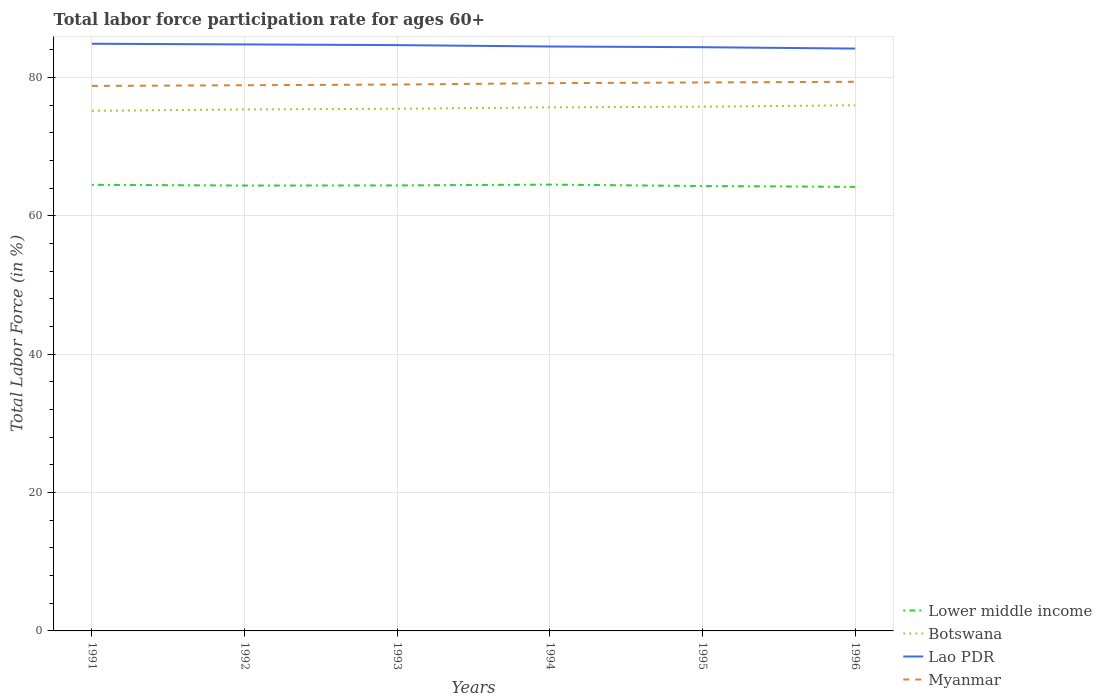Does the line corresponding to Lower middle income intersect with the line corresponding to Botswana?
Your answer should be very brief. No. Is the number of lines equal to the number of legend labels?
Make the answer very short. Yes. Across all years, what is the maximum labor force participation rate in Myanmar?
Your response must be concise. 78.8. In which year was the labor force participation rate in Lower middle income maximum?
Keep it short and to the point. 1996. What is the total labor force participation rate in Myanmar in the graph?
Offer a very short reply. -0.4. What is the difference between the highest and the second highest labor force participation rate in Myanmar?
Offer a very short reply. 0.6. Is the labor force participation rate in Lower middle income strictly greater than the labor force participation rate in Myanmar over the years?
Make the answer very short. Yes. How many lines are there?
Your response must be concise. 4. Are the values on the major ticks of Y-axis written in scientific E-notation?
Make the answer very short. No. Does the graph contain any zero values?
Provide a short and direct response. No. Does the graph contain grids?
Offer a very short reply. Yes. What is the title of the graph?
Your answer should be compact. Total labor force participation rate for ages 60+. Does "United Kingdom" appear as one of the legend labels in the graph?
Offer a very short reply. No. What is the label or title of the X-axis?
Your response must be concise. Years. What is the label or title of the Y-axis?
Make the answer very short. Total Labor Force (in %). What is the Total Labor Force (in %) in Lower middle income in 1991?
Your answer should be very brief. 64.5. What is the Total Labor Force (in %) of Botswana in 1991?
Offer a terse response. 75.2. What is the Total Labor Force (in %) of Lao PDR in 1991?
Your response must be concise. 84.9. What is the Total Labor Force (in %) in Myanmar in 1991?
Keep it short and to the point. 78.8. What is the Total Labor Force (in %) in Lower middle income in 1992?
Ensure brevity in your answer.  64.4. What is the Total Labor Force (in %) in Botswana in 1992?
Make the answer very short. 75.4. What is the Total Labor Force (in %) of Lao PDR in 1992?
Your answer should be very brief. 84.8. What is the Total Labor Force (in %) in Myanmar in 1992?
Your answer should be compact. 78.9. What is the Total Labor Force (in %) in Lower middle income in 1993?
Give a very brief answer. 64.41. What is the Total Labor Force (in %) in Botswana in 1993?
Offer a very short reply. 75.5. What is the Total Labor Force (in %) in Lao PDR in 1993?
Offer a terse response. 84.7. What is the Total Labor Force (in %) of Myanmar in 1993?
Make the answer very short. 79. What is the Total Labor Force (in %) of Lower middle income in 1994?
Provide a short and direct response. 64.53. What is the Total Labor Force (in %) of Botswana in 1994?
Your answer should be compact. 75.7. What is the Total Labor Force (in %) of Lao PDR in 1994?
Your answer should be very brief. 84.5. What is the Total Labor Force (in %) of Myanmar in 1994?
Offer a terse response. 79.2. What is the Total Labor Force (in %) of Lower middle income in 1995?
Offer a terse response. 64.33. What is the Total Labor Force (in %) in Botswana in 1995?
Offer a terse response. 75.8. What is the Total Labor Force (in %) in Lao PDR in 1995?
Your answer should be very brief. 84.4. What is the Total Labor Force (in %) in Myanmar in 1995?
Keep it short and to the point. 79.3. What is the Total Labor Force (in %) in Lower middle income in 1996?
Offer a terse response. 64.2. What is the Total Labor Force (in %) of Botswana in 1996?
Provide a short and direct response. 76. What is the Total Labor Force (in %) in Lao PDR in 1996?
Offer a terse response. 84.2. What is the Total Labor Force (in %) of Myanmar in 1996?
Provide a short and direct response. 79.4. Across all years, what is the maximum Total Labor Force (in %) in Lower middle income?
Your answer should be compact. 64.53. Across all years, what is the maximum Total Labor Force (in %) in Botswana?
Your answer should be compact. 76. Across all years, what is the maximum Total Labor Force (in %) in Lao PDR?
Keep it short and to the point. 84.9. Across all years, what is the maximum Total Labor Force (in %) in Myanmar?
Give a very brief answer. 79.4. Across all years, what is the minimum Total Labor Force (in %) of Lower middle income?
Ensure brevity in your answer.  64.2. Across all years, what is the minimum Total Labor Force (in %) of Botswana?
Offer a very short reply. 75.2. Across all years, what is the minimum Total Labor Force (in %) of Lao PDR?
Your answer should be compact. 84.2. Across all years, what is the minimum Total Labor Force (in %) in Myanmar?
Ensure brevity in your answer.  78.8. What is the total Total Labor Force (in %) of Lower middle income in the graph?
Your response must be concise. 386.37. What is the total Total Labor Force (in %) in Botswana in the graph?
Ensure brevity in your answer.  453.6. What is the total Total Labor Force (in %) in Lao PDR in the graph?
Ensure brevity in your answer.  507.5. What is the total Total Labor Force (in %) of Myanmar in the graph?
Your answer should be very brief. 474.6. What is the difference between the Total Labor Force (in %) of Lower middle income in 1991 and that in 1992?
Your answer should be compact. 0.1. What is the difference between the Total Labor Force (in %) in Botswana in 1991 and that in 1992?
Ensure brevity in your answer.  -0.2. What is the difference between the Total Labor Force (in %) in Myanmar in 1991 and that in 1992?
Provide a succinct answer. -0.1. What is the difference between the Total Labor Force (in %) of Lower middle income in 1991 and that in 1993?
Offer a terse response. 0.08. What is the difference between the Total Labor Force (in %) in Botswana in 1991 and that in 1993?
Ensure brevity in your answer.  -0.3. What is the difference between the Total Labor Force (in %) of Lao PDR in 1991 and that in 1993?
Offer a very short reply. 0.2. What is the difference between the Total Labor Force (in %) in Myanmar in 1991 and that in 1993?
Your answer should be very brief. -0.2. What is the difference between the Total Labor Force (in %) of Lower middle income in 1991 and that in 1994?
Provide a succinct answer. -0.03. What is the difference between the Total Labor Force (in %) in Myanmar in 1991 and that in 1994?
Keep it short and to the point. -0.4. What is the difference between the Total Labor Force (in %) of Lower middle income in 1991 and that in 1995?
Offer a terse response. 0.17. What is the difference between the Total Labor Force (in %) in Botswana in 1991 and that in 1995?
Make the answer very short. -0.6. What is the difference between the Total Labor Force (in %) of Lower middle income in 1991 and that in 1996?
Make the answer very short. 0.29. What is the difference between the Total Labor Force (in %) of Botswana in 1991 and that in 1996?
Provide a short and direct response. -0.8. What is the difference between the Total Labor Force (in %) of Lao PDR in 1991 and that in 1996?
Make the answer very short. 0.7. What is the difference between the Total Labor Force (in %) of Lower middle income in 1992 and that in 1993?
Provide a short and direct response. -0.02. What is the difference between the Total Labor Force (in %) of Myanmar in 1992 and that in 1993?
Keep it short and to the point. -0.1. What is the difference between the Total Labor Force (in %) of Lower middle income in 1992 and that in 1994?
Provide a succinct answer. -0.13. What is the difference between the Total Labor Force (in %) of Lao PDR in 1992 and that in 1994?
Offer a terse response. 0.3. What is the difference between the Total Labor Force (in %) in Lower middle income in 1992 and that in 1995?
Offer a terse response. 0.07. What is the difference between the Total Labor Force (in %) in Botswana in 1992 and that in 1995?
Your response must be concise. -0.4. What is the difference between the Total Labor Force (in %) in Lao PDR in 1992 and that in 1995?
Provide a succinct answer. 0.4. What is the difference between the Total Labor Force (in %) of Myanmar in 1992 and that in 1995?
Keep it short and to the point. -0.4. What is the difference between the Total Labor Force (in %) of Lower middle income in 1992 and that in 1996?
Your answer should be very brief. 0.19. What is the difference between the Total Labor Force (in %) of Lower middle income in 1993 and that in 1994?
Provide a succinct answer. -0.12. What is the difference between the Total Labor Force (in %) in Myanmar in 1993 and that in 1994?
Your response must be concise. -0.2. What is the difference between the Total Labor Force (in %) in Lower middle income in 1993 and that in 1995?
Offer a very short reply. 0.08. What is the difference between the Total Labor Force (in %) in Lower middle income in 1993 and that in 1996?
Offer a very short reply. 0.21. What is the difference between the Total Labor Force (in %) in Botswana in 1993 and that in 1996?
Give a very brief answer. -0.5. What is the difference between the Total Labor Force (in %) of Myanmar in 1993 and that in 1996?
Offer a terse response. -0.4. What is the difference between the Total Labor Force (in %) in Lower middle income in 1994 and that in 1995?
Your response must be concise. 0.2. What is the difference between the Total Labor Force (in %) in Botswana in 1994 and that in 1995?
Give a very brief answer. -0.1. What is the difference between the Total Labor Force (in %) of Lao PDR in 1994 and that in 1995?
Your answer should be very brief. 0.1. What is the difference between the Total Labor Force (in %) in Lower middle income in 1994 and that in 1996?
Provide a succinct answer. 0.33. What is the difference between the Total Labor Force (in %) in Lao PDR in 1994 and that in 1996?
Ensure brevity in your answer.  0.3. What is the difference between the Total Labor Force (in %) in Lower middle income in 1995 and that in 1996?
Make the answer very short. 0.13. What is the difference between the Total Labor Force (in %) of Botswana in 1995 and that in 1996?
Ensure brevity in your answer.  -0.2. What is the difference between the Total Labor Force (in %) of Lower middle income in 1991 and the Total Labor Force (in %) of Botswana in 1992?
Your answer should be compact. -10.9. What is the difference between the Total Labor Force (in %) in Lower middle income in 1991 and the Total Labor Force (in %) in Lao PDR in 1992?
Provide a succinct answer. -20.3. What is the difference between the Total Labor Force (in %) in Lower middle income in 1991 and the Total Labor Force (in %) in Myanmar in 1992?
Offer a terse response. -14.4. What is the difference between the Total Labor Force (in %) in Botswana in 1991 and the Total Labor Force (in %) in Myanmar in 1992?
Your answer should be compact. -3.7. What is the difference between the Total Labor Force (in %) of Lower middle income in 1991 and the Total Labor Force (in %) of Botswana in 1993?
Provide a succinct answer. -11. What is the difference between the Total Labor Force (in %) in Lower middle income in 1991 and the Total Labor Force (in %) in Lao PDR in 1993?
Provide a succinct answer. -20.2. What is the difference between the Total Labor Force (in %) of Lower middle income in 1991 and the Total Labor Force (in %) of Myanmar in 1993?
Your response must be concise. -14.5. What is the difference between the Total Labor Force (in %) in Botswana in 1991 and the Total Labor Force (in %) in Lao PDR in 1993?
Offer a very short reply. -9.5. What is the difference between the Total Labor Force (in %) in Lao PDR in 1991 and the Total Labor Force (in %) in Myanmar in 1993?
Keep it short and to the point. 5.9. What is the difference between the Total Labor Force (in %) in Lower middle income in 1991 and the Total Labor Force (in %) in Botswana in 1994?
Offer a very short reply. -11.2. What is the difference between the Total Labor Force (in %) in Lower middle income in 1991 and the Total Labor Force (in %) in Lao PDR in 1994?
Offer a terse response. -20. What is the difference between the Total Labor Force (in %) of Lower middle income in 1991 and the Total Labor Force (in %) of Myanmar in 1994?
Keep it short and to the point. -14.7. What is the difference between the Total Labor Force (in %) in Botswana in 1991 and the Total Labor Force (in %) in Myanmar in 1994?
Offer a terse response. -4. What is the difference between the Total Labor Force (in %) in Lao PDR in 1991 and the Total Labor Force (in %) in Myanmar in 1994?
Your response must be concise. 5.7. What is the difference between the Total Labor Force (in %) of Lower middle income in 1991 and the Total Labor Force (in %) of Botswana in 1995?
Your answer should be very brief. -11.3. What is the difference between the Total Labor Force (in %) in Lower middle income in 1991 and the Total Labor Force (in %) in Lao PDR in 1995?
Your answer should be compact. -19.9. What is the difference between the Total Labor Force (in %) of Lower middle income in 1991 and the Total Labor Force (in %) of Myanmar in 1995?
Ensure brevity in your answer.  -14.8. What is the difference between the Total Labor Force (in %) in Botswana in 1991 and the Total Labor Force (in %) in Myanmar in 1995?
Give a very brief answer. -4.1. What is the difference between the Total Labor Force (in %) of Lower middle income in 1991 and the Total Labor Force (in %) of Botswana in 1996?
Provide a short and direct response. -11.5. What is the difference between the Total Labor Force (in %) in Lower middle income in 1991 and the Total Labor Force (in %) in Lao PDR in 1996?
Your answer should be very brief. -19.7. What is the difference between the Total Labor Force (in %) of Lower middle income in 1991 and the Total Labor Force (in %) of Myanmar in 1996?
Offer a very short reply. -14.9. What is the difference between the Total Labor Force (in %) of Botswana in 1991 and the Total Labor Force (in %) of Myanmar in 1996?
Your response must be concise. -4.2. What is the difference between the Total Labor Force (in %) of Lao PDR in 1991 and the Total Labor Force (in %) of Myanmar in 1996?
Offer a very short reply. 5.5. What is the difference between the Total Labor Force (in %) in Lower middle income in 1992 and the Total Labor Force (in %) in Botswana in 1993?
Make the answer very short. -11.1. What is the difference between the Total Labor Force (in %) in Lower middle income in 1992 and the Total Labor Force (in %) in Lao PDR in 1993?
Ensure brevity in your answer.  -20.3. What is the difference between the Total Labor Force (in %) of Lower middle income in 1992 and the Total Labor Force (in %) of Myanmar in 1993?
Your answer should be compact. -14.6. What is the difference between the Total Labor Force (in %) in Botswana in 1992 and the Total Labor Force (in %) in Lao PDR in 1993?
Keep it short and to the point. -9.3. What is the difference between the Total Labor Force (in %) in Botswana in 1992 and the Total Labor Force (in %) in Myanmar in 1993?
Give a very brief answer. -3.6. What is the difference between the Total Labor Force (in %) in Lower middle income in 1992 and the Total Labor Force (in %) in Botswana in 1994?
Your response must be concise. -11.3. What is the difference between the Total Labor Force (in %) in Lower middle income in 1992 and the Total Labor Force (in %) in Lao PDR in 1994?
Keep it short and to the point. -20.1. What is the difference between the Total Labor Force (in %) of Lower middle income in 1992 and the Total Labor Force (in %) of Myanmar in 1994?
Your response must be concise. -14.8. What is the difference between the Total Labor Force (in %) in Lower middle income in 1992 and the Total Labor Force (in %) in Botswana in 1995?
Provide a short and direct response. -11.4. What is the difference between the Total Labor Force (in %) in Lower middle income in 1992 and the Total Labor Force (in %) in Lao PDR in 1995?
Your answer should be very brief. -20. What is the difference between the Total Labor Force (in %) in Lower middle income in 1992 and the Total Labor Force (in %) in Myanmar in 1995?
Make the answer very short. -14.9. What is the difference between the Total Labor Force (in %) of Botswana in 1992 and the Total Labor Force (in %) of Lao PDR in 1995?
Offer a terse response. -9. What is the difference between the Total Labor Force (in %) of Lao PDR in 1992 and the Total Labor Force (in %) of Myanmar in 1995?
Provide a short and direct response. 5.5. What is the difference between the Total Labor Force (in %) of Lower middle income in 1992 and the Total Labor Force (in %) of Botswana in 1996?
Give a very brief answer. -11.6. What is the difference between the Total Labor Force (in %) in Lower middle income in 1992 and the Total Labor Force (in %) in Lao PDR in 1996?
Make the answer very short. -19.8. What is the difference between the Total Labor Force (in %) of Lower middle income in 1992 and the Total Labor Force (in %) of Myanmar in 1996?
Your answer should be compact. -15. What is the difference between the Total Labor Force (in %) in Botswana in 1992 and the Total Labor Force (in %) in Myanmar in 1996?
Your answer should be compact. -4. What is the difference between the Total Labor Force (in %) in Lower middle income in 1993 and the Total Labor Force (in %) in Botswana in 1994?
Offer a terse response. -11.29. What is the difference between the Total Labor Force (in %) in Lower middle income in 1993 and the Total Labor Force (in %) in Lao PDR in 1994?
Offer a very short reply. -20.09. What is the difference between the Total Labor Force (in %) of Lower middle income in 1993 and the Total Labor Force (in %) of Myanmar in 1994?
Provide a short and direct response. -14.79. What is the difference between the Total Labor Force (in %) in Lower middle income in 1993 and the Total Labor Force (in %) in Botswana in 1995?
Provide a succinct answer. -11.39. What is the difference between the Total Labor Force (in %) of Lower middle income in 1993 and the Total Labor Force (in %) of Lao PDR in 1995?
Your answer should be very brief. -19.99. What is the difference between the Total Labor Force (in %) in Lower middle income in 1993 and the Total Labor Force (in %) in Myanmar in 1995?
Your answer should be very brief. -14.89. What is the difference between the Total Labor Force (in %) in Lower middle income in 1993 and the Total Labor Force (in %) in Botswana in 1996?
Your answer should be very brief. -11.59. What is the difference between the Total Labor Force (in %) in Lower middle income in 1993 and the Total Labor Force (in %) in Lao PDR in 1996?
Ensure brevity in your answer.  -19.79. What is the difference between the Total Labor Force (in %) of Lower middle income in 1993 and the Total Labor Force (in %) of Myanmar in 1996?
Your answer should be compact. -14.99. What is the difference between the Total Labor Force (in %) in Botswana in 1993 and the Total Labor Force (in %) in Myanmar in 1996?
Ensure brevity in your answer.  -3.9. What is the difference between the Total Labor Force (in %) in Lower middle income in 1994 and the Total Labor Force (in %) in Botswana in 1995?
Your answer should be very brief. -11.27. What is the difference between the Total Labor Force (in %) in Lower middle income in 1994 and the Total Labor Force (in %) in Lao PDR in 1995?
Offer a terse response. -19.87. What is the difference between the Total Labor Force (in %) of Lower middle income in 1994 and the Total Labor Force (in %) of Myanmar in 1995?
Give a very brief answer. -14.77. What is the difference between the Total Labor Force (in %) of Botswana in 1994 and the Total Labor Force (in %) of Lao PDR in 1995?
Provide a short and direct response. -8.7. What is the difference between the Total Labor Force (in %) of Botswana in 1994 and the Total Labor Force (in %) of Myanmar in 1995?
Your answer should be compact. -3.6. What is the difference between the Total Labor Force (in %) in Lao PDR in 1994 and the Total Labor Force (in %) in Myanmar in 1995?
Make the answer very short. 5.2. What is the difference between the Total Labor Force (in %) in Lower middle income in 1994 and the Total Labor Force (in %) in Botswana in 1996?
Provide a succinct answer. -11.47. What is the difference between the Total Labor Force (in %) in Lower middle income in 1994 and the Total Labor Force (in %) in Lao PDR in 1996?
Offer a terse response. -19.67. What is the difference between the Total Labor Force (in %) in Lower middle income in 1994 and the Total Labor Force (in %) in Myanmar in 1996?
Your answer should be compact. -14.87. What is the difference between the Total Labor Force (in %) of Botswana in 1994 and the Total Labor Force (in %) of Myanmar in 1996?
Offer a very short reply. -3.7. What is the difference between the Total Labor Force (in %) of Lao PDR in 1994 and the Total Labor Force (in %) of Myanmar in 1996?
Offer a terse response. 5.1. What is the difference between the Total Labor Force (in %) in Lower middle income in 1995 and the Total Labor Force (in %) in Botswana in 1996?
Your response must be concise. -11.67. What is the difference between the Total Labor Force (in %) of Lower middle income in 1995 and the Total Labor Force (in %) of Lao PDR in 1996?
Give a very brief answer. -19.87. What is the difference between the Total Labor Force (in %) of Lower middle income in 1995 and the Total Labor Force (in %) of Myanmar in 1996?
Make the answer very short. -15.07. What is the difference between the Total Labor Force (in %) in Botswana in 1995 and the Total Labor Force (in %) in Myanmar in 1996?
Make the answer very short. -3.6. What is the difference between the Total Labor Force (in %) of Lao PDR in 1995 and the Total Labor Force (in %) of Myanmar in 1996?
Keep it short and to the point. 5. What is the average Total Labor Force (in %) of Lower middle income per year?
Offer a very short reply. 64.39. What is the average Total Labor Force (in %) in Botswana per year?
Give a very brief answer. 75.6. What is the average Total Labor Force (in %) of Lao PDR per year?
Make the answer very short. 84.58. What is the average Total Labor Force (in %) in Myanmar per year?
Your answer should be compact. 79.1. In the year 1991, what is the difference between the Total Labor Force (in %) of Lower middle income and Total Labor Force (in %) of Botswana?
Offer a very short reply. -10.7. In the year 1991, what is the difference between the Total Labor Force (in %) in Lower middle income and Total Labor Force (in %) in Lao PDR?
Give a very brief answer. -20.4. In the year 1991, what is the difference between the Total Labor Force (in %) of Lower middle income and Total Labor Force (in %) of Myanmar?
Your answer should be compact. -14.3. In the year 1991, what is the difference between the Total Labor Force (in %) in Lao PDR and Total Labor Force (in %) in Myanmar?
Provide a succinct answer. 6.1. In the year 1992, what is the difference between the Total Labor Force (in %) of Lower middle income and Total Labor Force (in %) of Botswana?
Ensure brevity in your answer.  -11. In the year 1992, what is the difference between the Total Labor Force (in %) of Lower middle income and Total Labor Force (in %) of Lao PDR?
Your answer should be compact. -20.4. In the year 1992, what is the difference between the Total Labor Force (in %) of Lower middle income and Total Labor Force (in %) of Myanmar?
Your answer should be compact. -14.5. In the year 1992, what is the difference between the Total Labor Force (in %) in Lao PDR and Total Labor Force (in %) in Myanmar?
Ensure brevity in your answer.  5.9. In the year 1993, what is the difference between the Total Labor Force (in %) of Lower middle income and Total Labor Force (in %) of Botswana?
Give a very brief answer. -11.09. In the year 1993, what is the difference between the Total Labor Force (in %) in Lower middle income and Total Labor Force (in %) in Lao PDR?
Make the answer very short. -20.29. In the year 1993, what is the difference between the Total Labor Force (in %) in Lower middle income and Total Labor Force (in %) in Myanmar?
Your answer should be very brief. -14.59. In the year 1993, what is the difference between the Total Labor Force (in %) in Botswana and Total Labor Force (in %) in Myanmar?
Provide a succinct answer. -3.5. In the year 1993, what is the difference between the Total Labor Force (in %) in Lao PDR and Total Labor Force (in %) in Myanmar?
Your answer should be compact. 5.7. In the year 1994, what is the difference between the Total Labor Force (in %) of Lower middle income and Total Labor Force (in %) of Botswana?
Your answer should be very brief. -11.17. In the year 1994, what is the difference between the Total Labor Force (in %) in Lower middle income and Total Labor Force (in %) in Lao PDR?
Keep it short and to the point. -19.97. In the year 1994, what is the difference between the Total Labor Force (in %) in Lower middle income and Total Labor Force (in %) in Myanmar?
Keep it short and to the point. -14.67. In the year 1994, what is the difference between the Total Labor Force (in %) of Botswana and Total Labor Force (in %) of Lao PDR?
Make the answer very short. -8.8. In the year 1995, what is the difference between the Total Labor Force (in %) in Lower middle income and Total Labor Force (in %) in Botswana?
Offer a very short reply. -11.47. In the year 1995, what is the difference between the Total Labor Force (in %) of Lower middle income and Total Labor Force (in %) of Lao PDR?
Provide a short and direct response. -20.07. In the year 1995, what is the difference between the Total Labor Force (in %) of Lower middle income and Total Labor Force (in %) of Myanmar?
Ensure brevity in your answer.  -14.97. In the year 1995, what is the difference between the Total Labor Force (in %) of Botswana and Total Labor Force (in %) of Myanmar?
Ensure brevity in your answer.  -3.5. In the year 1996, what is the difference between the Total Labor Force (in %) in Lower middle income and Total Labor Force (in %) in Botswana?
Keep it short and to the point. -11.8. In the year 1996, what is the difference between the Total Labor Force (in %) of Lower middle income and Total Labor Force (in %) of Lao PDR?
Keep it short and to the point. -20. In the year 1996, what is the difference between the Total Labor Force (in %) of Lower middle income and Total Labor Force (in %) of Myanmar?
Your answer should be compact. -15.2. In the year 1996, what is the difference between the Total Labor Force (in %) in Botswana and Total Labor Force (in %) in Lao PDR?
Keep it short and to the point. -8.2. What is the ratio of the Total Labor Force (in %) of Lower middle income in 1991 to that in 1992?
Your answer should be very brief. 1. What is the ratio of the Total Labor Force (in %) in Botswana in 1991 to that in 1992?
Your answer should be compact. 1. What is the ratio of the Total Labor Force (in %) in Myanmar in 1991 to that in 1992?
Your answer should be very brief. 1. What is the ratio of the Total Labor Force (in %) of Lao PDR in 1991 to that in 1993?
Offer a terse response. 1. What is the ratio of the Total Labor Force (in %) of Myanmar in 1991 to that in 1993?
Make the answer very short. 1. What is the ratio of the Total Labor Force (in %) in Myanmar in 1991 to that in 1994?
Offer a very short reply. 0.99. What is the ratio of the Total Labor Force (in %) of Lao PDR in 1991 to that in 1995?
Make the answer very short. 1.01. What is the ratio of the Total Labor Force (in %) of Myanmar in 1991 to that in 1995?
Give a very brief answer. 0.99. What is the ratio of the Total Labor Force (in %) in Lower middle income in 1991 to that in 1996?
Make the answer very short. 1. What is the ratio of the Total Labor Force (in %) in Lao PDR in 1991 to that in 1996?
Provide a short and direct response. 1.01. What is the ratio of the Total Labor Force (in %) in Botswana in 1992 to that in 1993?
Your answer should be very brief. 1. What is the ratio of the Total Labor Force (in %) of Lao PDR in 1992 to that in 1993?
Offer a very short reply. 1. What is the ratio of the Total Labor Force (in %) of Lower middle income in 1992 to that in 1994?
Make the answer very short. 1. What is the ratio of the Total Labor Force (in %) in Botswana in 1992 to that in 1994?
Offer a terse response. 1. What is the ratio of the Total Labor Force (in %) of Lao PDR in 1992 to that in 1994?
Provide a short and direct response. 1. What is the ratio of the Total Labor Force (in %) of Botswana in 1992 to that in 1995?
Ensure brevity in your answer.  0.99. What is the ratio of the Total Labor Force (in %) in Lao PDR in 1992 to that in 1995?
Provide a short and direct response. 1. What is the ratio of the Total Labor Force (in %) of Lower middle income in 1992 to that in 1996?
Your answer should be very brief. 1. What is the ratio of the Total Labor Force (in %) of Lao PDR in 1992 to that in 1996?
Offer a terse response. 1.01. What is the ratio of the Total Labor Force (in %) of Myanmar in 1992 to that in 1996?
Ensure brevity in your answer.  0.99. What is the ratio of the Total Labor Force (in %) in Lower middle income in 1993 to that in 1994?
Your answer should be compact. 1. What is the ratio of the Total Labor Force (in %) of Myanmar in 1993 to that in 1994?
Your response must be concise. 1. What is the ratio of the Total Labor Force (in %) in Botswana in 1993 to that in 1995?
Provide a succinct answer. 1. What is the ratio of the Total Labor Force (in %) of Lower middle income in 1993 to that in 1996?
Offer a very short reply. 1. What is the ratio of the Total Labor Force (in %) in Botswana in 1993 to that in 1996?
Your answer should be very brief. 0.99. What is the ratio of the Total Labor Force (in %) in Lao PDR in 1993 to that in 1996?
Give a very brief answer. 1.01. What is the ratio of the Total Labor Force (in %) of Lao PDR in 1994 to that in 1995?
Your answer should be very brief. 1. What is the ratio of the Total Labor Force (in %) of Myanmar in 1995 to that in 1996?
Make the answer very short. 1. What is the difference between the highest and the second highest Total Labor Force (in %) in Lower middle income?
Your answer should be very brief. 0.03. What is the difference between the highest and the second highest Total Labor Force (in %) of Botswana?
Provide a succinct answer. 0.2. What is the difference between the highest and the second highest Total Labor Force (in %) in Lao PDR?
Offer a terse response. 0.1. What is the difference between the highest and the lowest Total Labor Force (in %) of Lower middle income?
Ensure brevity in your answer.  0.33. 